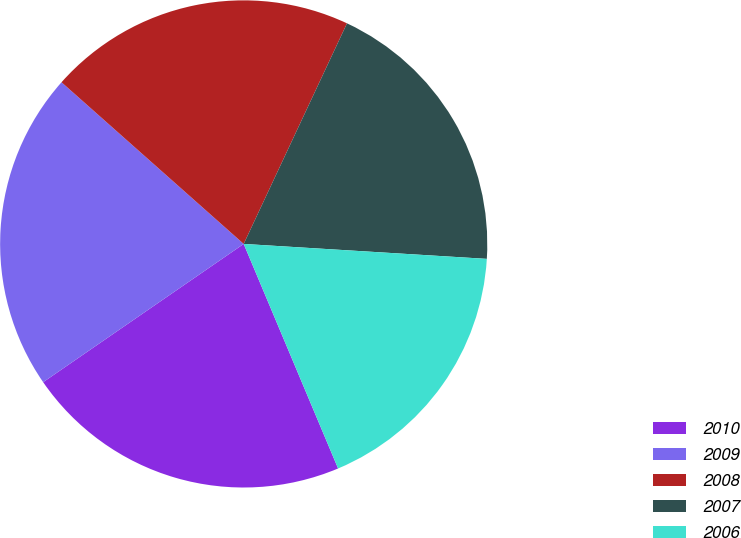Convert chart to OTSL. <chart><loc_0><loc_0><loc_500><loc_500><pie_chart><fcel>2010<fcel>2009<fcel>2008<fcel>2007<fcel>2006<nl><fcel>21.73%<fcel>21.16%<fcel>20.42%<fcel>19.01%<fcel>17.69%<nl></chart> 